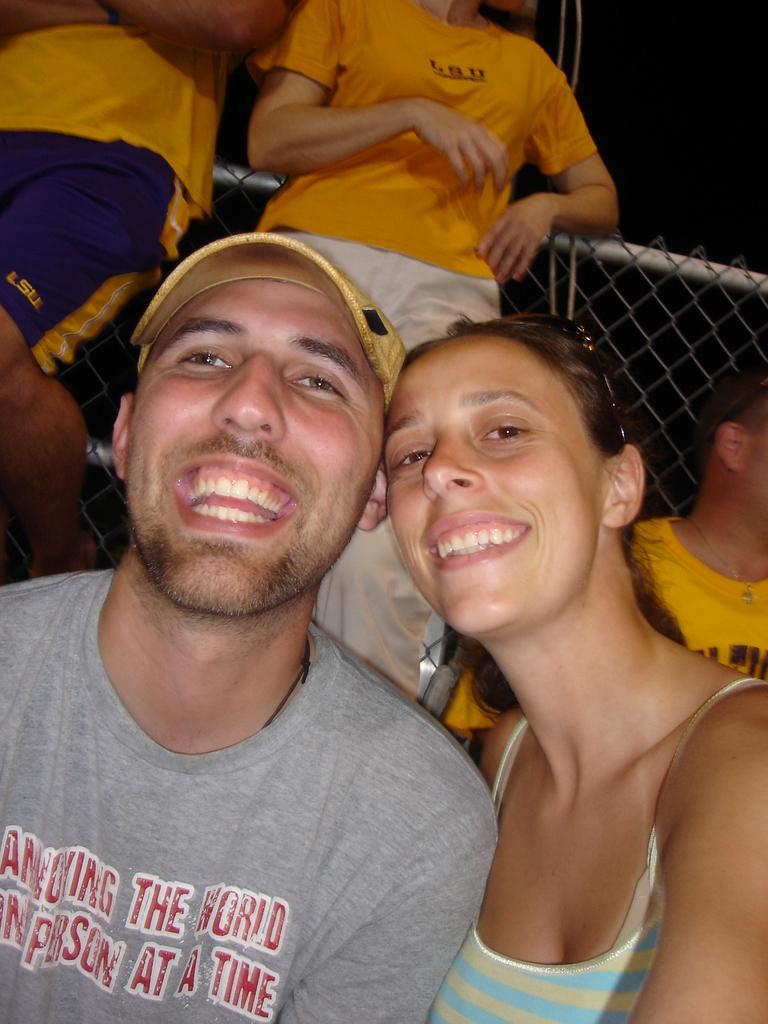How many people can be seen in the image? There are two people in the image. What are the expressions on the faces of the two people? Both people are smiling. Can you describe the people behind the two smiling people? There are other people visible behind the two smiling people. What can be seen in the background of the image? There is a mesh visible in the background of the image. What type of fowl can be seen flying in the image? There is no fowl visible in the image; it only features people and a mesh background. 